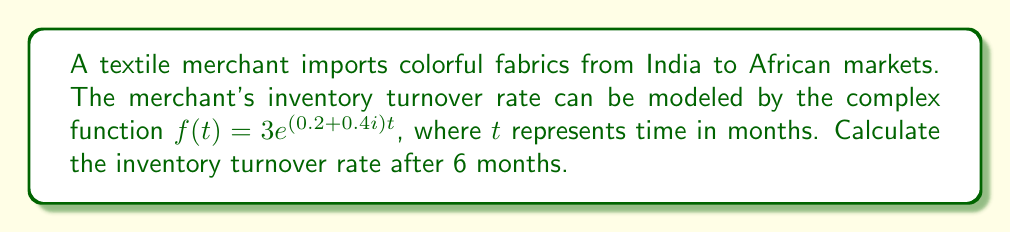Provide a solution to this math problem. To solve this problem, we need to follow these steps:

1) The given function is $f(t) = 3e^{(0.2+0.4i)t}$

2) We need to evaluate this function at $t = 6$ months:

   $f(6) = 3e^{(0.2+0.4i)6}$

3) Simplify the exponent:
   
   $f(6) = 3e^{1.2+2.4i}$

4) Using Euler's formula, $e^{a+bi} = e^a(\cos b + i\sin b)$, we can rewrite this as:

   $f(6) = 3e^{1.2}(\cos 2.4 + i\sin 2.4)$

5) Calculate $e^{1.2}$:
   
   $e^{1.2} \approx 3.3201$

6) Calculate $\cos 2.4$ and $\sin 2.4$:
   
   $\cos 2.4 \approx -0.7374$
   $\sin 2.4 \approx 0.6755$

7) Substitute these values:

   $f(6) \approx 3 * 3.3201 * (-0.7374 + 0.6755i)$

8) Simplify:

   $f(6) \approx -7.3448 + 6.7344i$

9) To get the magnitude (which represents the actual turnover rate), we use the formula $|a+bi| = \sqrt{a^2 + b^2}$:

   $|f(6)| = \sqrt{(-7.3448)^2 + (6.7344)^2} \approx 9.9604$

Therefore, the inventory turnover rate after 6 months is approximately 9.9604.
Answer: 9.9604 